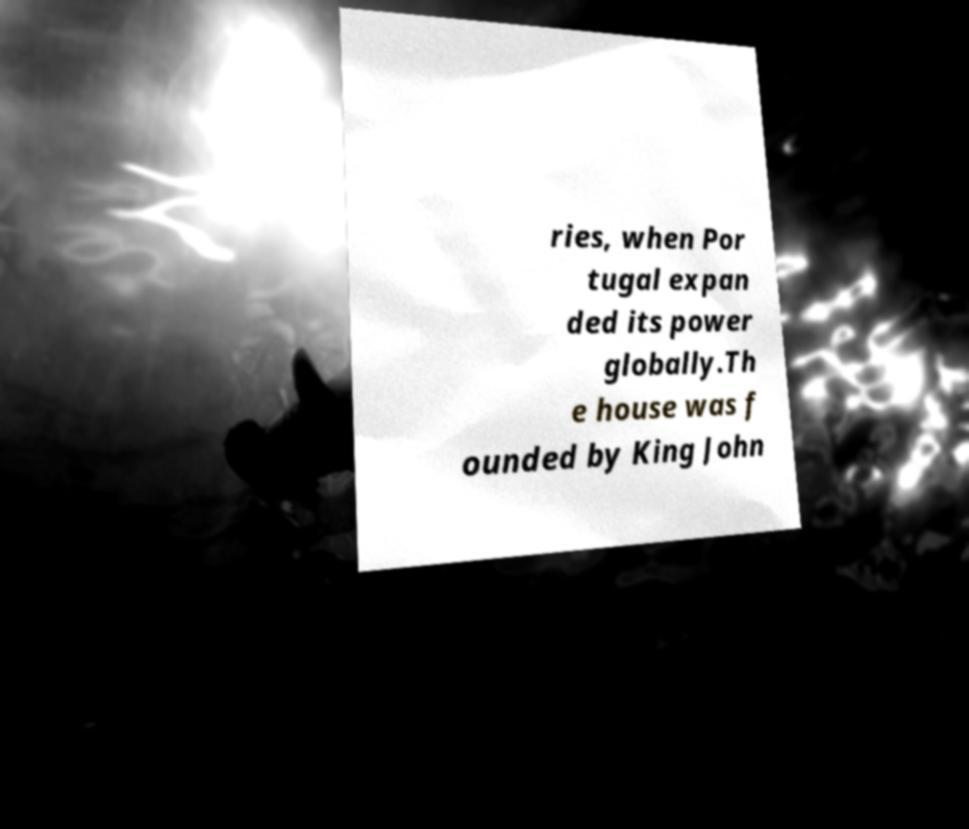Could you assist in decoding the text presented in this image and type it out clearly? ries, when Por tugal expan ded its power globally.Th e house was f ounded by King John 